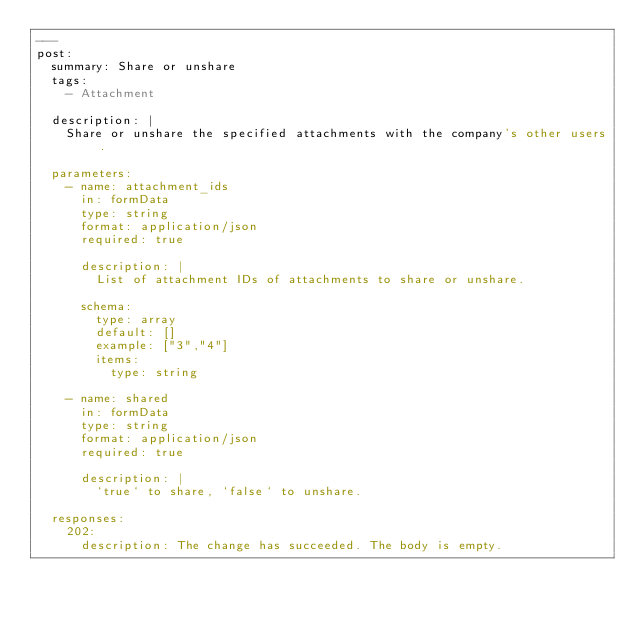Convert code to text. <code><loc_0><loc_0><loc_500><loc_500><_YAML_>---
post:
  summary: Share or unshare
  tags:
    - Attachment

  description: |
    Share or unshare the specified attachments with the company's other users.

  parameters:
    - name: attachment_ids
      in: formData
      type: string
      format: application/json
      required: true

      description: |
        List of attachment IDs of attachments to share or unshare.

      schema:
        type: array
        default: []
        example: ["3","4"]
        items:
          type: string

    - name: shared
      in: formData
      type: string
      format: application/json
      required: true

      description: |
        `true` to share, `false` to unshare.

  responses:
    202:
      description: The change has succeeded. The body is empty.
</code> 